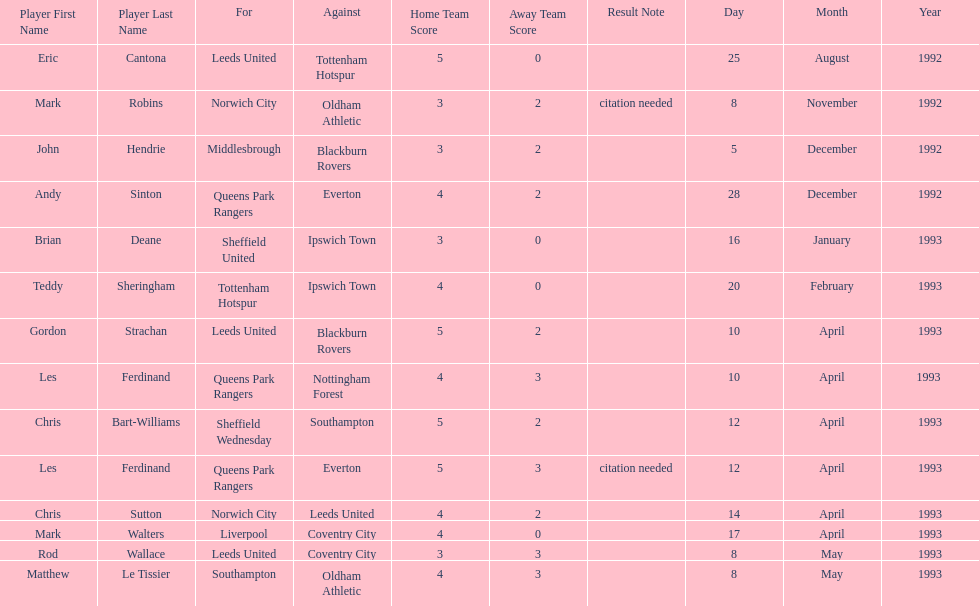What was the result of the match between queens park rangers and everton? 4-2. Can you give me this table as a dict? {'header': ['Player First Name', 'Player Last Name', 'For', 'Against', 'Home Team Score', 'Away Team Score', 'Result Note', 'Day', 'Month', 'Year'], 'rows': [['Eric', 'Cantona', 'Leeds United', 'Tottenham Hotspur', '5', '0', '', '25', 'August', '1992'], ['Mark', 'Robins', 'Norwich City', 'Oldham Athletic', '3', '2', 'citation needed', '8', 'November', '1992'], ['John', 'Hendrie', 'Middlesbrough', 'Blackburn Rovers', '3', '2', '', '5', 'December', '1992'], ['Andy', 'Sinton', 'Queens Park Rangers', 'Everton', '4', '2', '', '28', 'December', '1992'], ['Brian', 'Deane', 'Sheffield United', 'Ipswich Town', '3', '0', '', '16', 'January', '1993'], ['Teddy', 'Sheringham', 'Tottenham Hotspur', 'Ipswich Town', '4', '0', '', '20', 'February', '1993'], ['Gordon', 'Strachan', 'Leeds United', 'Blackburn Rovers', '5', '2', '', '10', 'April', '1993'], ['Les', 'Ferdinand', 'Queens Park Rangers', 'Nottingham Forest', '4', '3', '', '10', 'April', '1993 '], ['Chris', 'Bart-Williams', 'Sheffield Wednesday', 'Southampton', '5', '2', '', '12', 'April', '1993'], ['Les', 'Ferdinand', 'Queens Park Rangers', 'Everton', '5', '3', 'citation needed', '12', 'April', '1993'], ['Chris', 'Sutton', 'Norwich City', 'Leeds United', '4', '2', '', '14', 'April', '1993'], ['Mark', 'Walters', 'Liverpool', 'Coventry City', '4', '0', '', '17', 'April', '1993'], ['Rod', 'Wallace', 'Leeds United', 'Coventry City', '3', '3', '', '8', 'May', '1993'], ['Matthew', 'Le Tissier', 'Southampton', 'Oldham Athletic', '4', '3', '', '8', 'May', '1993']]} 